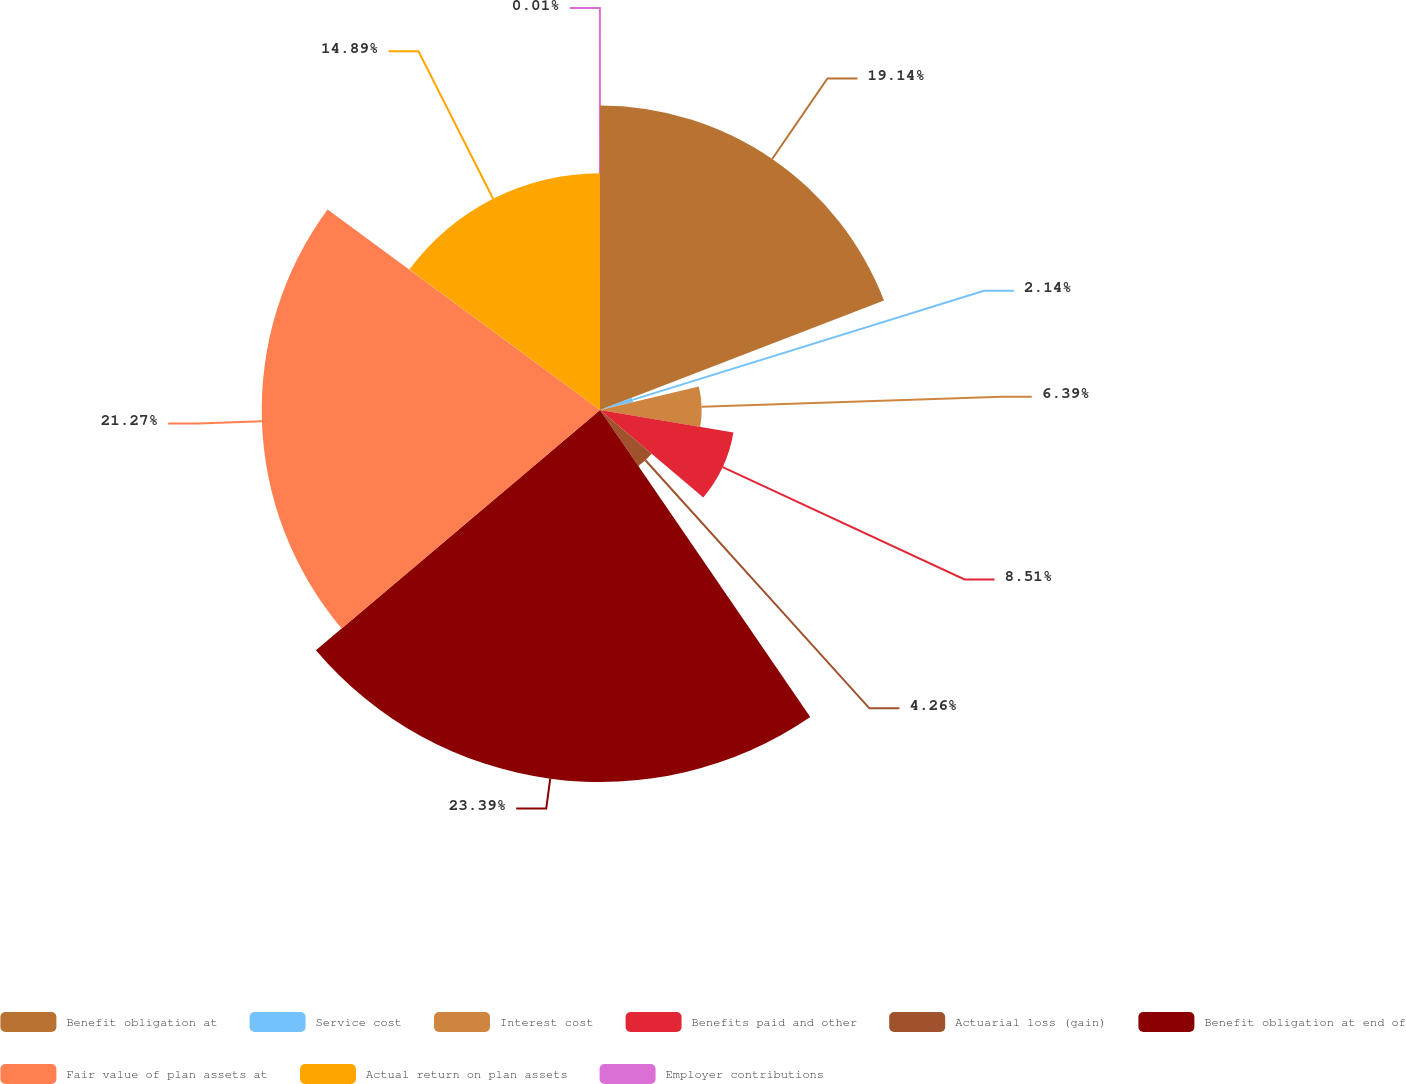<chart> <loc_0><loc_0><loc_500><loc_500><pie_chart><fcel>Benefit obligation at<fcel>Service cost<fcel>Interest cost<fcel>Benefits paid and other<fcel>Actuarial loss (gain)<fcel>Benefit obligation at end of<fcel>Fair value of plan assets at<fcel>Actual return on plan assets<fcel>Employer contributions<nl><fcel>19.14%<fcel>2.14%<fcel>6.39%<fcel>8.51%<fcel>4.26%<fcel>23.39%<fcel>21.27%<fcel>14.89%<fcel>0.01%<nl></chart> 